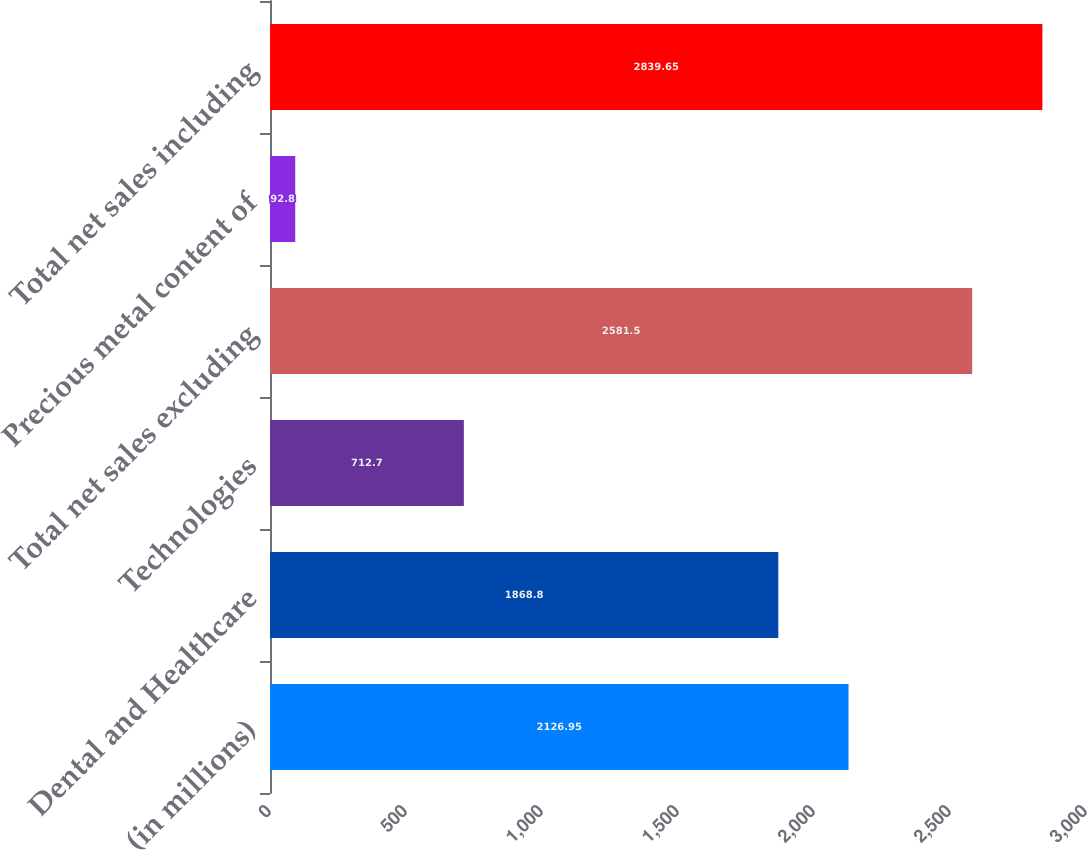<chart> <loc_0><loc_0><loc_500><loc_500><bar_chart><fcel>(in millions)<fcel>Dental and Healthcare<fcel>Technologies<fcel>Total net sales excluding<fcel>Precious metal content of<fcel>Total net sales including<nl><fcel>2126.95<fcel>1868.8<fcel>712.7<fcel>2581.5<fcel>92.8<fcel>2839.65<nl></chart> 